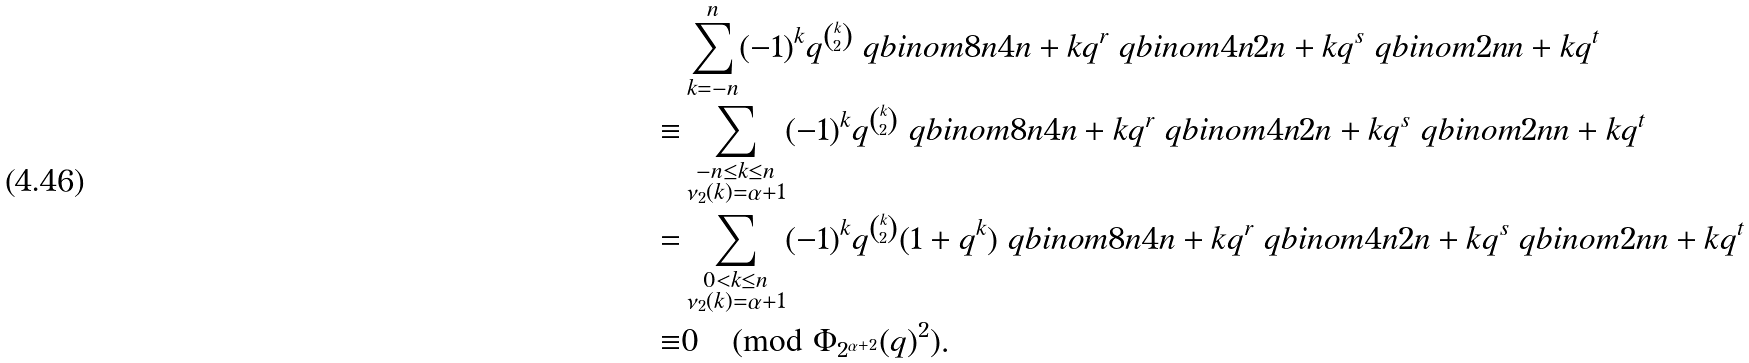Convert formula to latex. <formula><loc_0><loc_0><loc_500><loc_500>& \sum _ { k = - n } ^ { n } ( - 1 ) ^ { k } q ^ { \binom { k } { 2 } } \ q b i n o m { 8 n } { 4 n + k } q ^ { r } \ q b i n o m { 4 n } { 2 n + k } q ^ { s } \ q b i n o m { 2 n } { n + k } q ^ { t } \\ \equiv & \sum _ { \substack { - n \leq k \leq n \\ \nu _ { 2 } ( k ) = \alpha + 1 } } ( - 1 ) ^ { k } q ^ { \binom { k } { 2 } } \ q b i n o m { 8 n } { 4 n + k } q ^ { r } \ q b i n o m { 4 n } { 2 n + k } q ^ { s } \ q b i n o m { 2 n } { n + k } q ^ { t } \\ = & \sum _ { \substack { 0 < k \leq n \\ \nu _ { 2 } ( k ) = \alpha + 1 } } ( - 1 ) ^ { k } q ^ { \binom { k } { 2 } } ( 1 + q ^ { k } ) \ q b i n o m { 8 n } { 4 n + k } q ^ { r } \ q b i n o m { 4 n } { 2 n + k } q ^ { s } \ q b i n o m { 2 n } { n + k } q ^ { t } \\ \equiv & 0 \pmod { \Phi _ { 2 ^ { \alpha + 2 } } ( q ) ^ { 2 } } .</formula> 